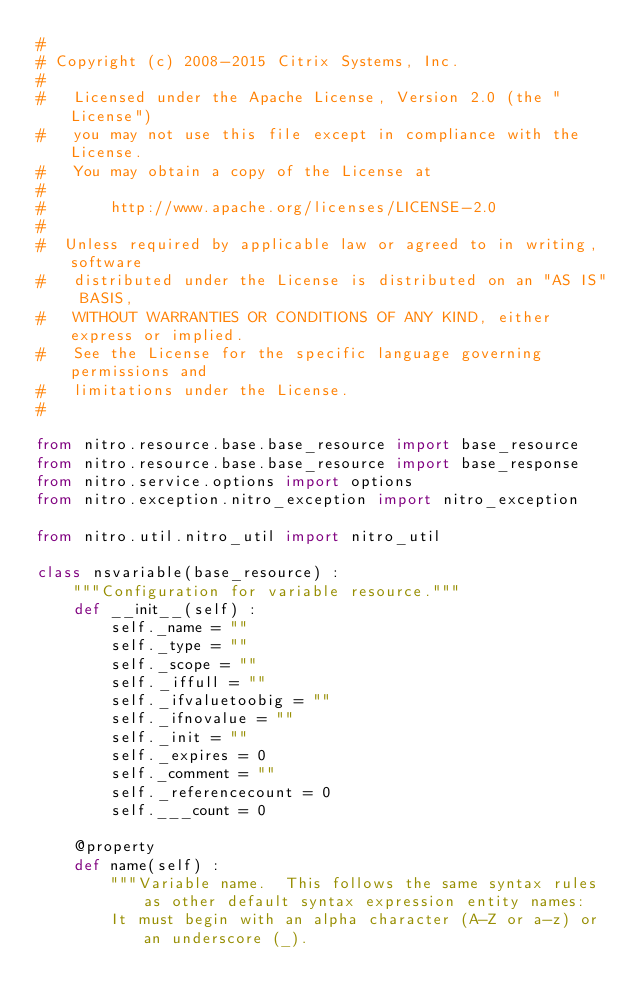<code> <loc_0><loc_0><loc_500><loc_500><_Python_>#
# Copyright (c) 2008-2015 Citrix Systems, Inc.
#
#   Licensed under the Apache License, Version 2.0 (the "License")
#   you may not use this file except in compliance with the License.
#   You may obtain a copy of the License at
#
#       http://www.apache.org/licenses/LICENSE-2.0
#
#  Unless required by applicable law or agreed to in writing, software
#   distributed under the License is distributed on an "AS IS" BASIS,
#   WITHOUT WARRANTIES OR CONDITIONS OF ANY KIND, either express or implied.
#   See the License for the specific language governing permissions and
#   limitations under the License.
#

from nitro.resource.base.base_resource import base_resource
from nitro.resource.base.base_resource import base_response
from nitro.service.options import options
from nitro.exception.nitro_exception import nitro_exception

from nitro.util.nitro_util import nitro_util

class nsvariable(base_resource) :
    """Configuration for variable resource."""
    def __init__(self) :
        self._name = ""
        self._type = ""
        self._scope = ""
        self._iffull = ""
        self._ifvaluetoobig = ""
        self._ifnovalue = ""
        self._init = ""
        self._expires = 0
        self._comment = ""
        self._referencecount = 0
        self.___count = 0

    @property
    def name(self) :
        """Variable name.  This follows the same syntax rules as other default syntax expression entity names:
        It must begin with an alpha character (A-Z or a-z) or an underscore (_).</code> 